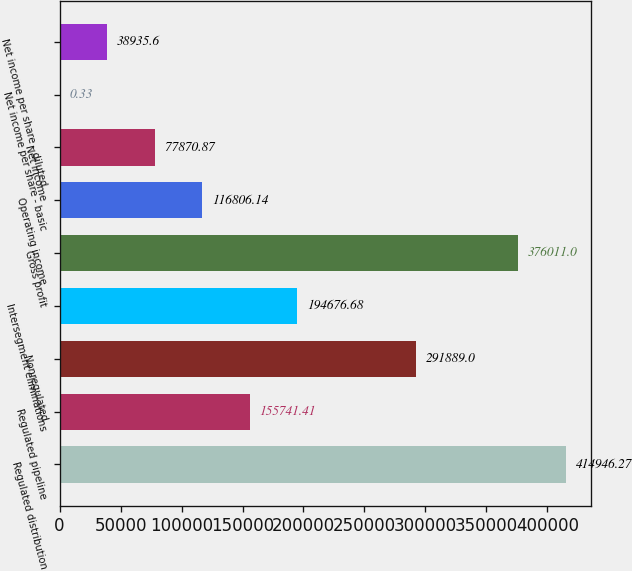<chart> <loc_0><loc_0><loc_500><loc_500><bar_chart><fcel>Regulated distribution<fcel>Regulated pipeline<fcel>Nonregulated<fcel>Intersegment eliminations<fcel>Gross profit<fcel>Operating income<fcel>Net income<fcel>Net income per share - basic<fcel>Net income per share - diluted<nl><fcel>414946<fcel>155741<fcel>291889<fcel>194677<fcel>376011<fcel>116806<fcel>77870.9<fcel>0.33<fcel>38935.6<nl></chart> 